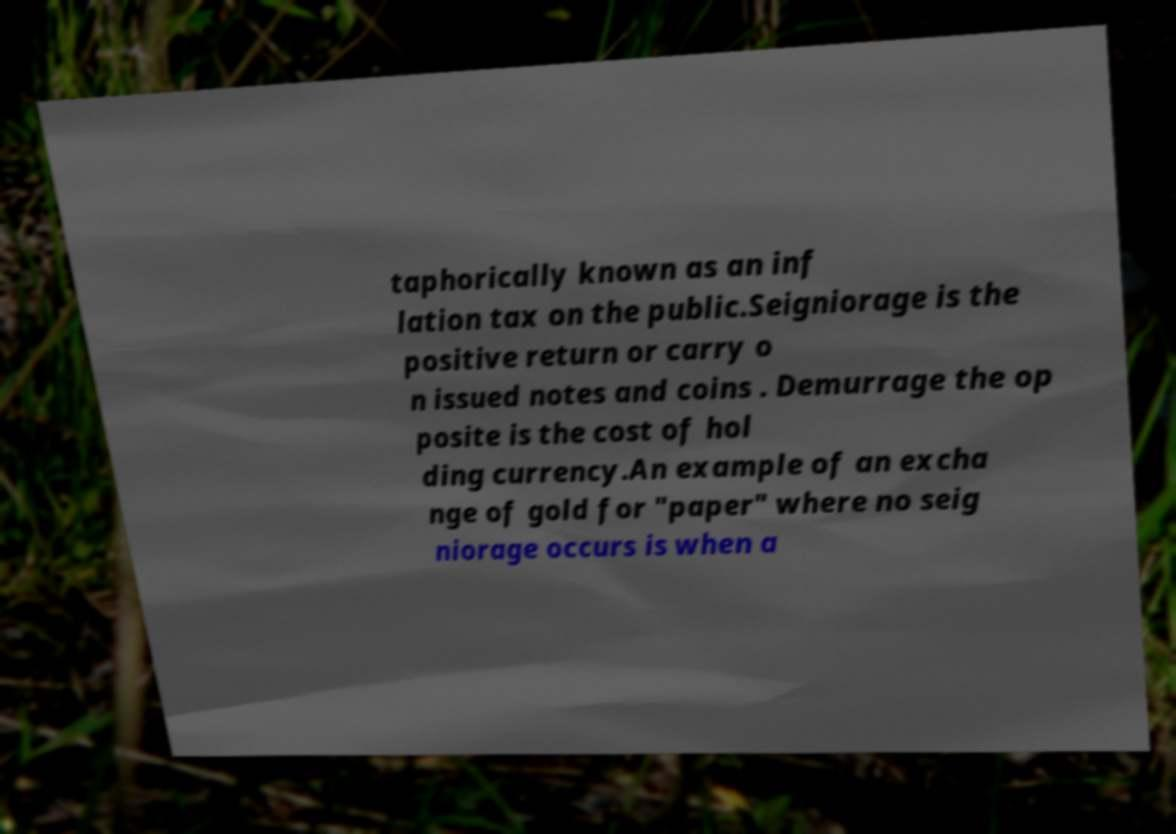Can you read and provide the text displayed in the image?This photo seems to have some interesting text. Can you extract and type it out for me? taphorically known as an inf lation tax on the public.Seigniorage is the positive return or carry o n issued notes and coins . Demurrage the op posite is the cost of hol ding currency.An example of an excha nge of gold for "paper" where no seig niorage occurs is when a 